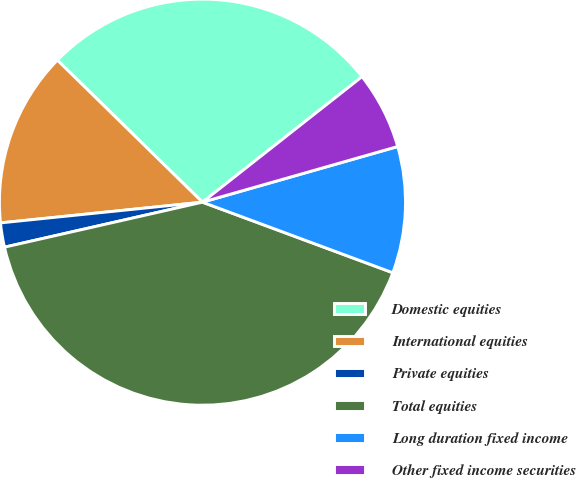Convert chart to OTSL. <chart><loc_0><loc_0><loc_500><loc_500><pie_chart><fcel>Domestic equities<fcel>International equities<fcel>Private equities<fcel>Total equities<fcel>Long duration fixed income<fcel>Other fixed income securities<nl><fcel>27.06%<fcel>13.96%<fcel>1.93%<fcel>40.79%<fcel>10.07%<fcel>6.19%<nl></chart> 